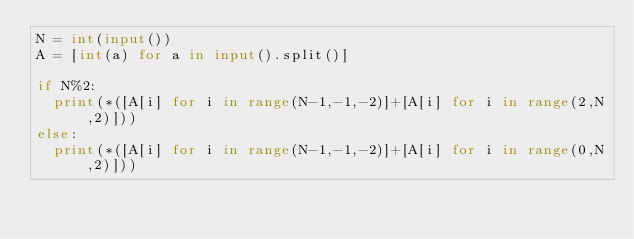Convert code to text. <code><loc_0><loc_0><loc_500><loc_500><_Python_>N = int(input())
A = [int(a) for a in input().split()]

if N%2:
  print(*([A[i] for i in range(N-1,-1,-2)]+[A[i] for i in range(2,N,2)]))
else:
  print(*([A[i] for i in range(N-1,-1,-2)]+[A[i] for i in range(0,N,2)]))</code> 